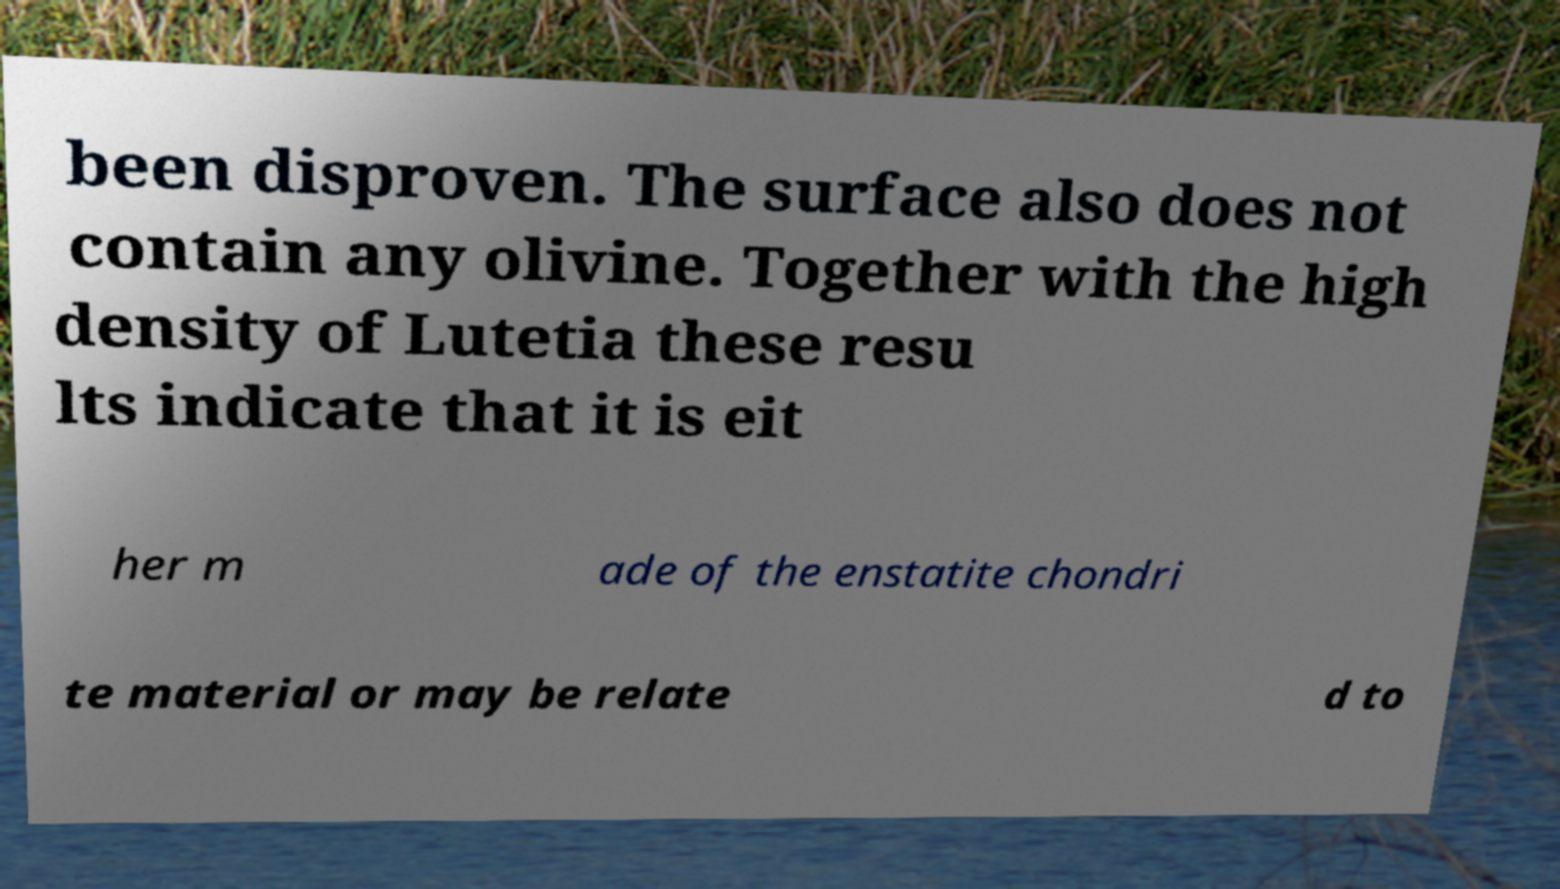For documentation purposes, I need the text within this image transcribed. Could you provide that? been disproven. The surface also does not contain any olivine. Together with the high density of Lutetia these resu lts indicate that it is eit her m ade of the enstatite chondri te material or may be relate d to 